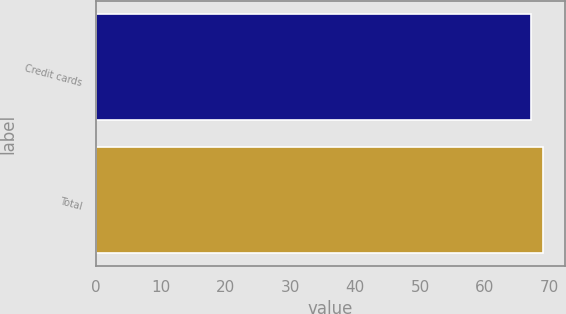Convert chart to OTSL. <chart><loc_0><loc_0><loc_500><loc_500><bar_chart><fcel>Credit cards<fcel>Total<nl><fcel>67.1<fcel>68.9<nl></chart> 